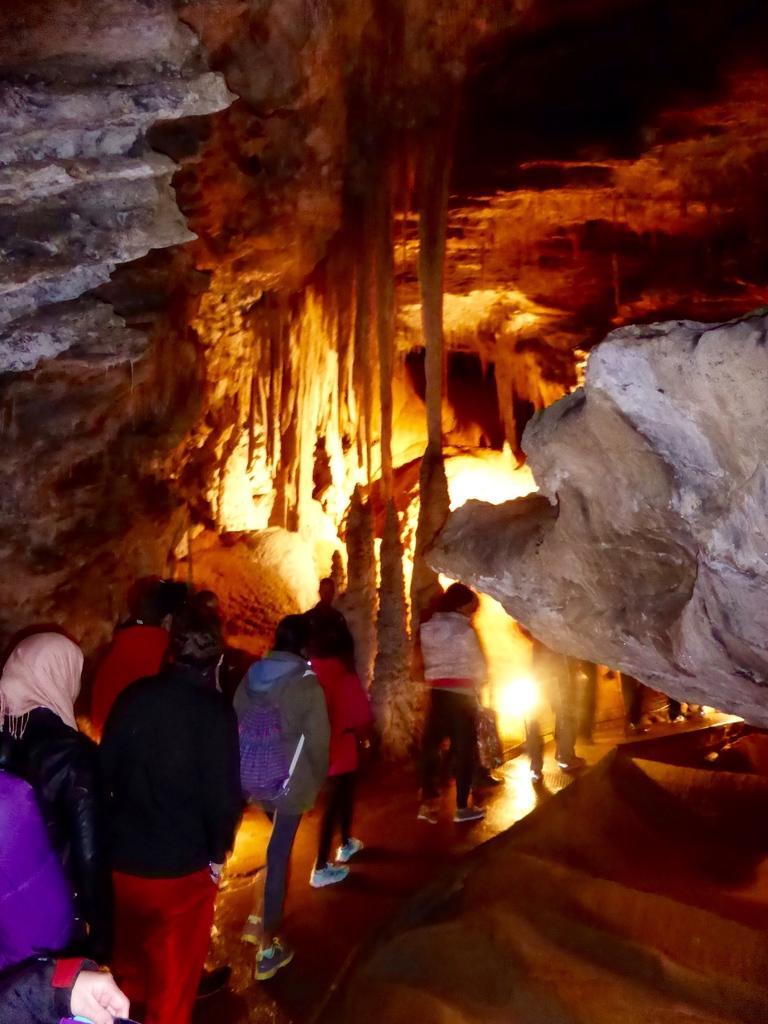Could you give a brief overview of what you see in this image? In this picture there are people in the bottom left side of the image, there is a subway in front of them and there are rocks in the background area of the image. 